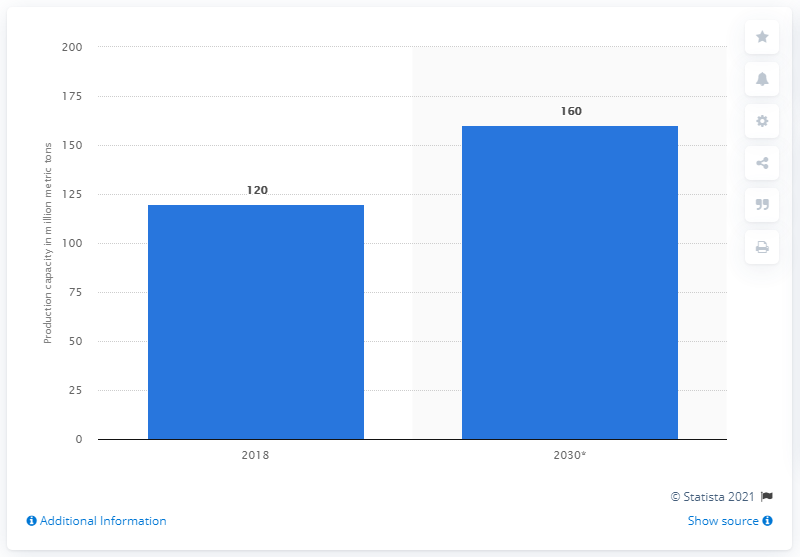Specify some key components in this picture. In 2018, the global production capacity of propylene was approximately 120 million tons. The global production capacity of propylene is expected to reach 160 million metric tons by 2030, according to industry experts. 